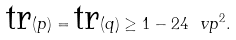Convert formula to latex. <formula><loc_0><loc_0><loc_500><loc_500>\text {tr} ( p ) = \text {tr} ( q ) \geq 1 - 2 4 \ v p ^ { 2 } .</formula> 